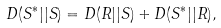<formula> <loc_0><loc_0><loc_500><loc_500>D ( S ^ { * } | | S ) = D ( R | | S ) + D ( S ^ { * } | | R ) ,</formula> 